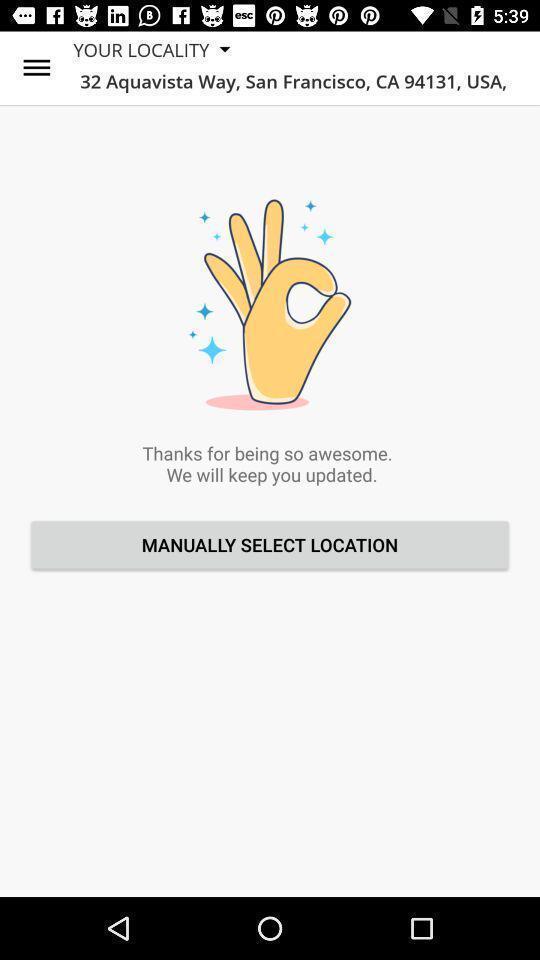Give me a narrative description of this picture. Screen page displaying place details. 